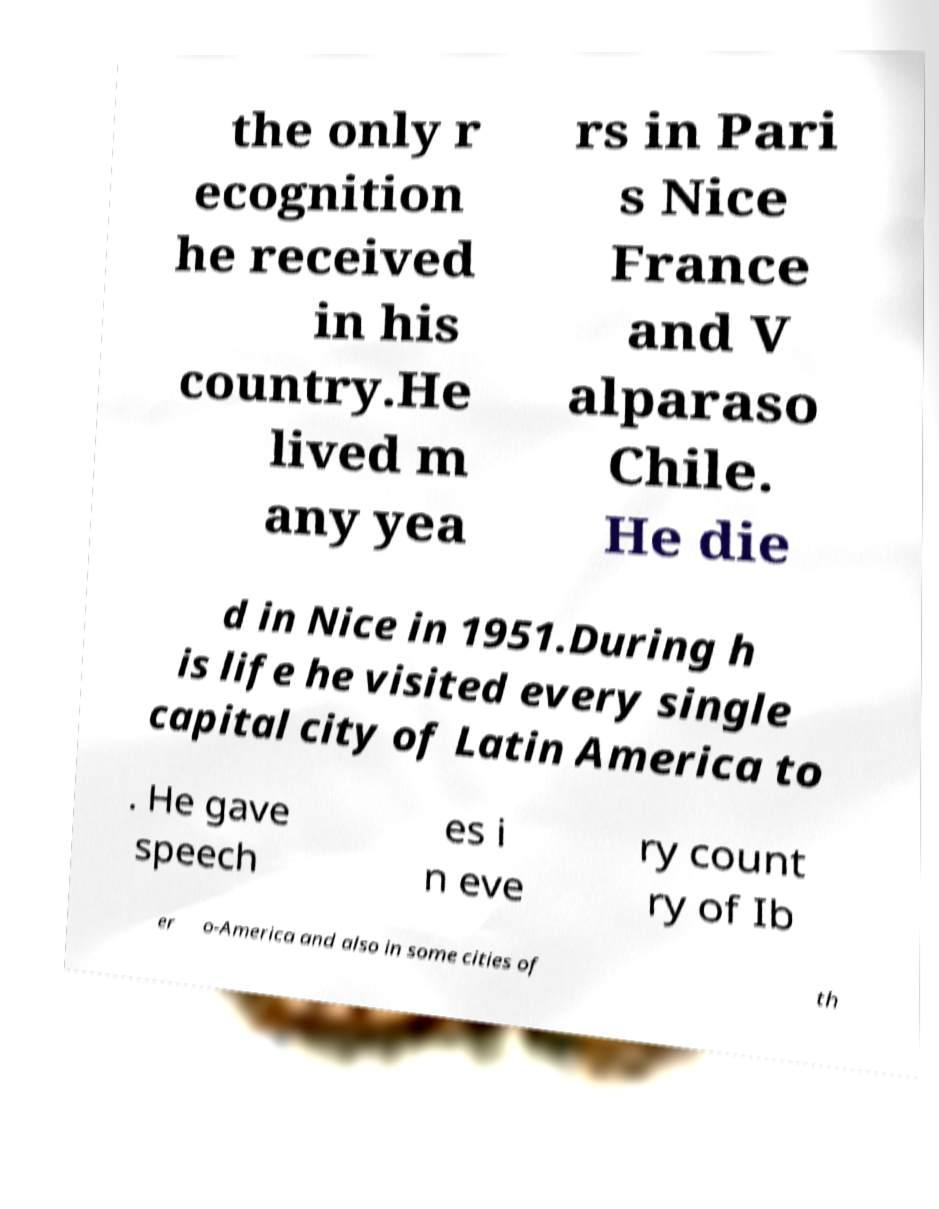Could you assist in decoding the text presented in this image and type it out clearly? the only r ecognition he received in his country.He lived m any yea rs in Pari s Nice France and V alparaso Chile. He die d in Nice in 1951.During h is life he visited every single capital city of Latin America to . He gave speech es i n eve ry count ry of Ib er o-America and also in some cities of th 